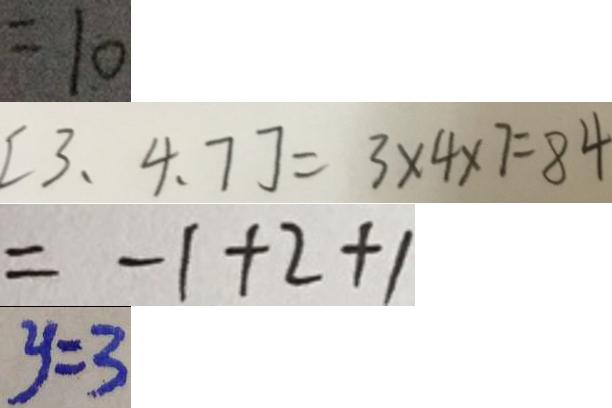Convert formula to latex. <formula><loc_0><loc_0><loc_500><loc_500>= 1 0 
 [ 3 、 4 、 7 ] = 3 \times 4 \times 7 = 8 4 
 = - 1 + 2 + 1 
 y = 3</formula> 